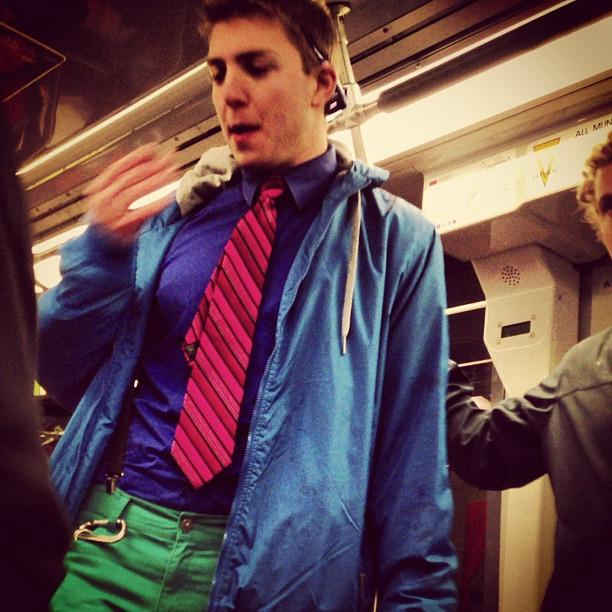What is clipped to the green pants?

Choices:
A) carabiner
B) paper clip
C) bobby pin
D) bread clip carabiner 